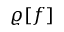Convert formula to latex. <formula><loc_0><loc_0><loc_500><loc_500>\varrho [ f ]</formula> 